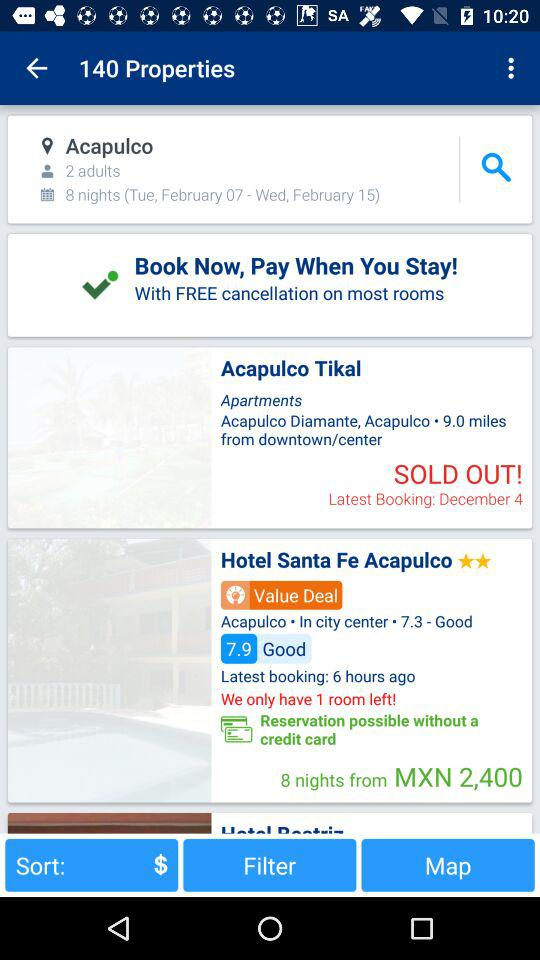What is the rating given to "The Hotel Santa Fe Acapulco"? The rating is 7.9. 